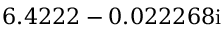<formula> <loc_0><loc_0><loc_500><loc_500>6 . 4 2 2 2 - 0 . 0 2 2 2 6 8 i</formula> 